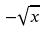Convert formula to latex. <formula><loc_0><loc_0><loc_500><loc_500>- \sqrt { x }</formula> 